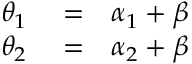<formula> <loc_0><loc_0><loc_500><loc_500>\begin{array} { r l r } { \theta _ { 1 } } & = } & { \alpha _ { 1 } + \beta } \\ { \theta _ { 2 } } & = } & { \alpha _ { 2 } + \beta } \end{array}</formula> 